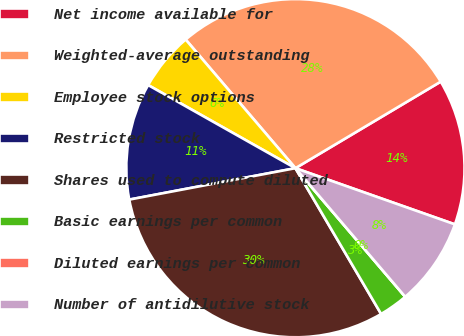Convert chart. <chart><loc_0><loc_0><loc_500><loc_500><pie_chart><fcel>Net income available for<fcel>Weighted-average outstanding<fcel>Employee stock options<fcel>Restricted stock<fcel>Shares used to compute diluted<fcel>Basic earnings per common<fcel>Diluted earnings per common<fcel>Number of antidilutive stock<nl><fcel>13.94%<fcel>27.69%<fcel>5.58%<fcel>11.15%<fcel>30.48%<fcel>2.79%<fcel>0.0%<fcel>8.36%<nl></chart> 